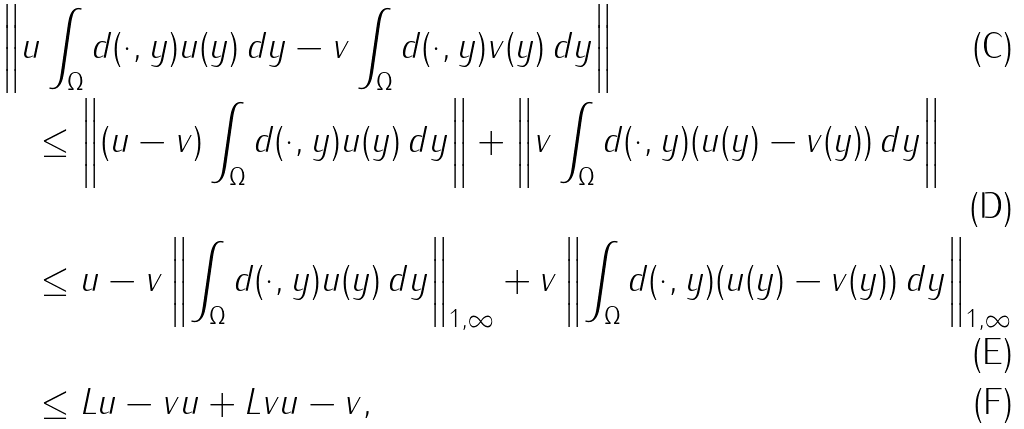Convert formula to latex. <formula><loc_0><loc_0><loc_500><loc_500>& \left \| u \int _ { \Omega } d ( \cdot , y ) u ( y ) \, d y - v \int _ { \Omega } d ( \cdot , y ) v ( y ) \, d y \right \| \\ & \quad \leq \left \| ( u - v ) \int _ { \Omega } d ( \cdot , y ) u ( y ) \, d y \right \| + \left \| v \int _ { \Omega } d ( \cdot , y ) ( u ( y ) - v ( y ) ) \, d y \right \| \\ & \quad \leq \| u - v \| \left \| \int _ { \Omega } d ( \cdot , y ) u ( y ) \, d y \right \| _ { 1 , \infty } + \| v \| \left \| \int _ { \Omega } d ( \cdot , y ) ( u ( y ) - v ( y ) ) \, d y \right \| _ { 1 , \infty } \\ & \quad \leq L \| u - v \| \| u \| + L \| v \| \| u - v \| ,</formula> 